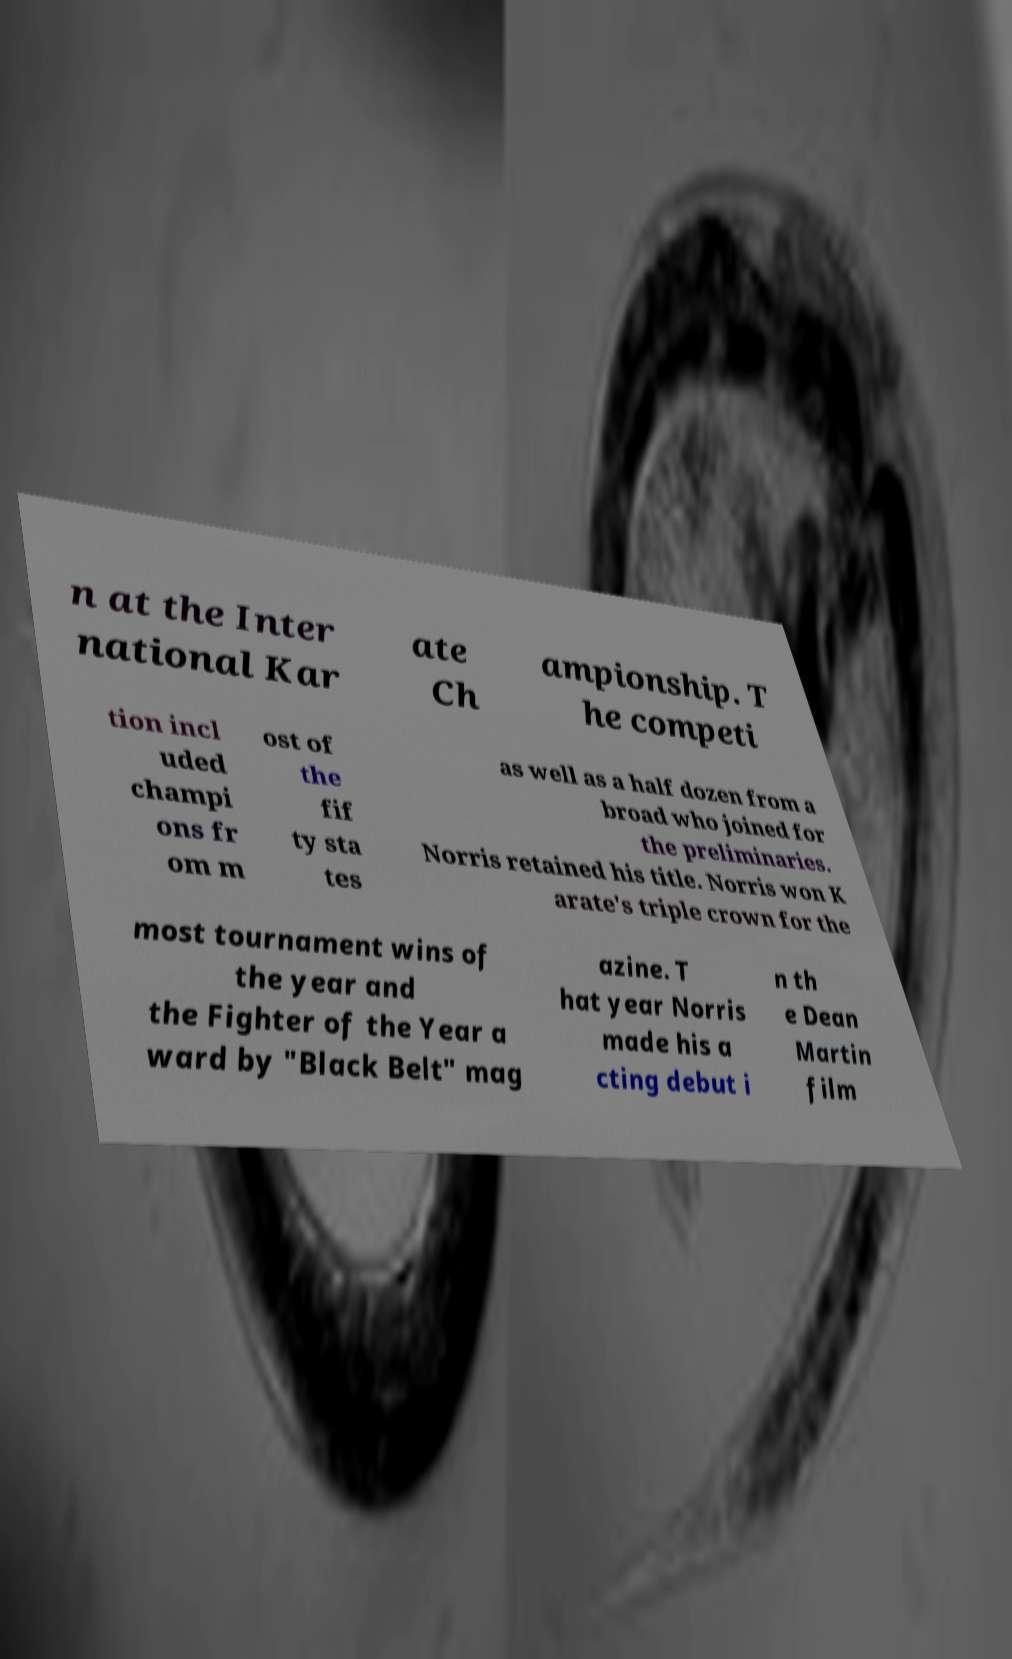Can you read and provide the text displayed in the image?This photo seems to have some interesting text. Can you extract and type it out for me? n at the Inter national Kar ate Ch ampionship. T he competi tion incl uded champi ons fr om m ost of the fif ty sta tes as well as a half dozen from a broad who joined for the preliminaries. Norris retained his title. Norris won K arate's triple crown for the most tournament wins of the year and the Fighter of the Year a ward by "Black Belt" mag azine. T hat year Norris made his a cting debut i n th e Dean Martin film 